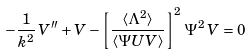<formula> <loc_0><loc_0><loc_500><loc_500>- \frac { 1 } { k ^ { 2 } } \, V ^ { \prime \prime } + V - \left [ \frac { \langle \Lambda ^ { 2 } \rangle } { \langle \Psi U V \rangle } \right ] ^ { 2 } \, \Psi ^ { 2 } \, V = 0</formula> 